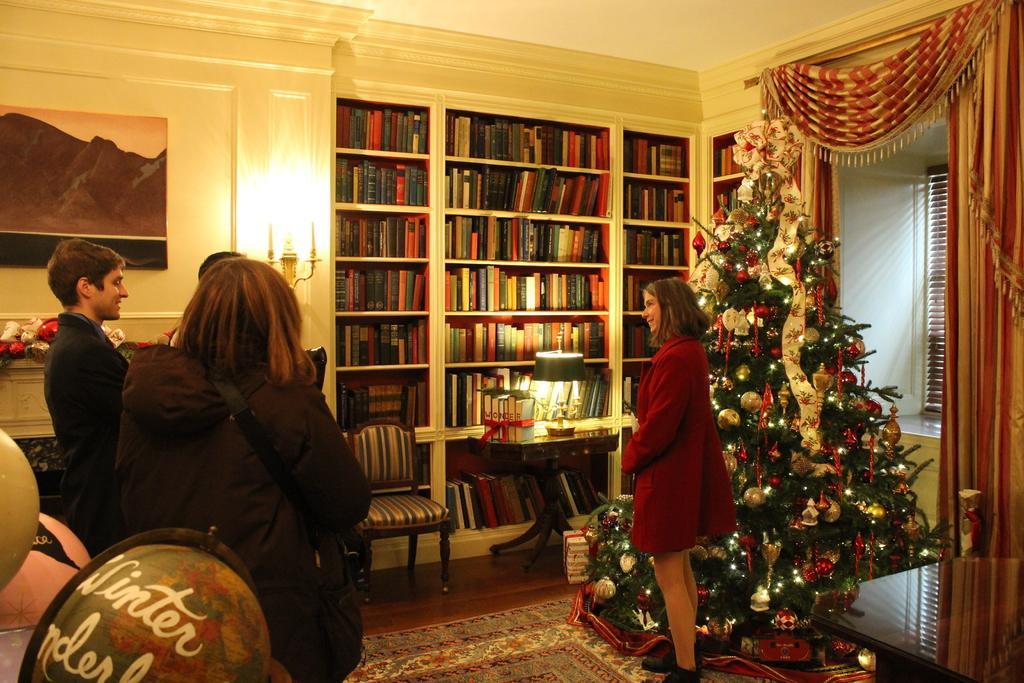Please provide a concise description of this image. This picture shows a woman standing near Christmas tree and we see a bookshelf and we see three person standing and we see a light 